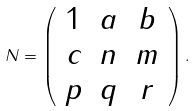Convert formula to latex. <formula><loc_0><loc_0><loc_500><loc_500>N = \left ( \begin{array} { c c c } 1 & a & b \\ c & n & m \\ p & q & r \end{array} \right ) .</formula> 